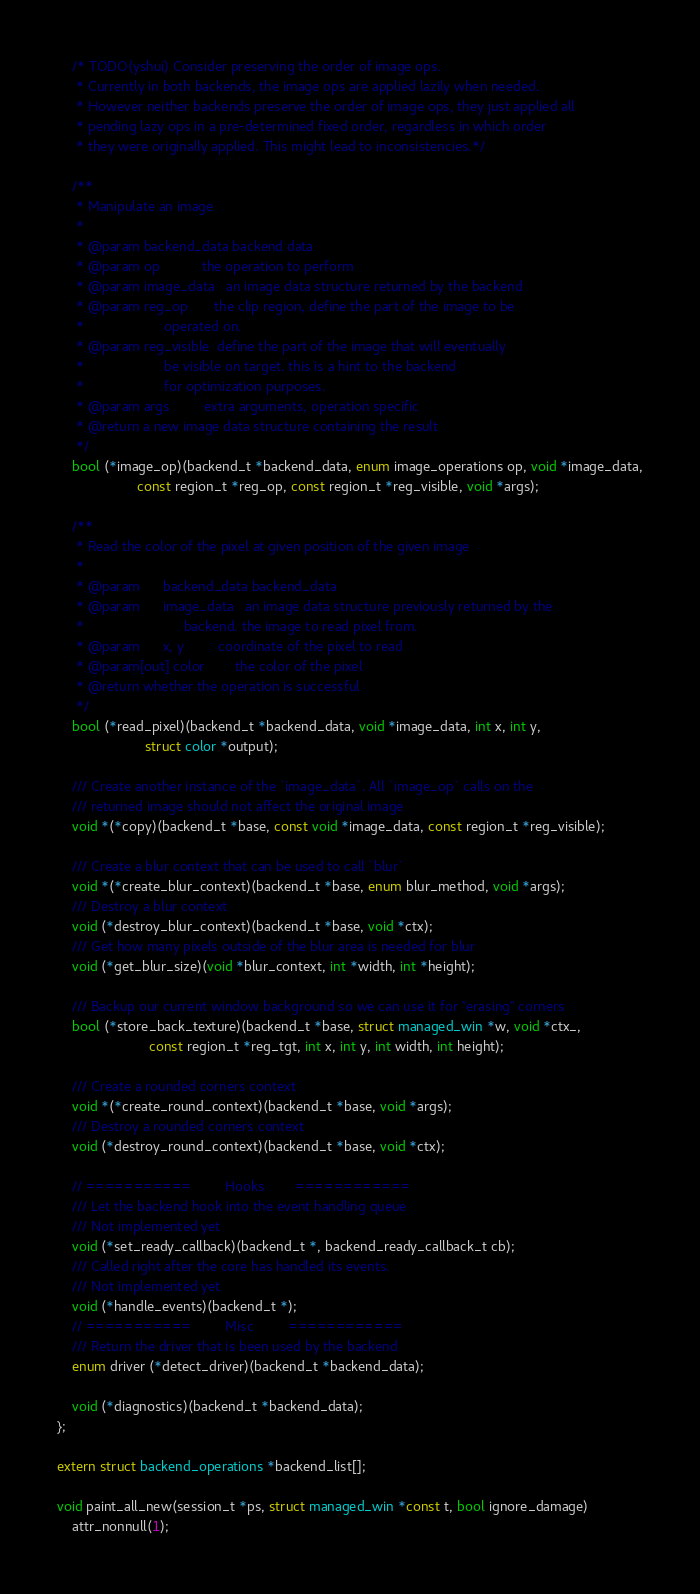Convert code to text. <code><loc_0><loc_0><loc_500><loc_500><_C_>	/* TODO(yshui) Consider preserving the order of image ops.
	 * Currently in both backends, the image ops are applied lazily when needed.
	 * However neither backends preserve the order of image ops, they just applied all
	 * pending lazy ops in a pre-determined fixed order, regardless in which order
	 * they were originally applied. This might lead to inconsistencies.*/

	/**
	 * Manipulate an image
	 *
	 * @param backend_data backend data
	 * @param op           the operation to perform
	 * @param image_data   an image data structure returned by the backend
	 * @param reg_op       the clip region, define the part of the image to be
	 *                     operated on.
	 * @param reg_visible  define the part of the image that will eventually
	 *                     be visible on target. this is a hint to the backend
	 *                     for optimization purposes.
	 * @param args         extra arguments, operation specific
	 * @return a new image data structure containing the result
	 */
	bool (*image_op)(backend_t *backend_data, enum image_operations op, void *image_data,
	                 const region_t *reg_op, const region_t *reg_visible, void *args);

	/**
	 * Read the color of the pixel at given position of the given image
	 *
	 * @param      backend_data backend_data
	 * @param      image_data   an image data structure previously returned by the
	 *                          backend. the image to read pixel from.
	 * @param      x, y         coordinate of the pixel to read
	 * @param[out] color        the color of the pixel
	 * @return whether the operation is successful
	 */
	bool (*read_pixel)(backend_t *backend_data, void *image_data, int x, int y,
	                   struct color *output);

	/// Create another instance of the `image_data`. All `image_op` calls on the
	/// returned image should not affect the original image
	void *(*copy)(backend_t *base, const void *image_data, const region_t *reg_visible);

	/// Create a blur context that can be used to call `blur`
	void *(*create_blur_context)(backend_t *base, enum blur_method, void *args);
	/// Destroy a blur context
	void (*destroy_blur_context)(backend_t *base, void *ctx);
	/// Get how many pixels outside of the blur area is needed for blur
	void (*get_blur_size)(void *blur_context, int *width, int *height);

	/// Backup our current window background so we can use it for "erasing" corners
	bool (*store_back_texture)(backend_t *base, struct managed_win *w, void *ctx_,
						const region_t *reg_tgt, int x, int y, int width, int height);

	/// Create a rounded corners context
	void *(*create_round_context)(backend_t *base, void *args);
	/// Destroy a rounded corners context
	void (*destroy_round_context)(backend_t *base, void *ctx);

	// ===========         Hooks        ============
	/// Let the backend hook into the event handling queue
	/// Not implemented yet
	void (*set_ready_callback)(backend_t *, backend_ready_callback_t cb);
	/// Called right after the core has handled its events.
	/// Not implemented yet
	void (*handle_events)(backend_t *);
	// ===========         Misc         ============
	/// Return the driver that is been used by the backend
	enum driver (*detect_driver)(backend_t *backend_data);

	void (*diagnostics)(backend_t *backend_data);
};

extern struct backend_operations *backend_list[];

void paint_all_new(session_t *ps, struct managed_win *const t, bool ignore_damage)
    attr_nonnull(1);
</code> 